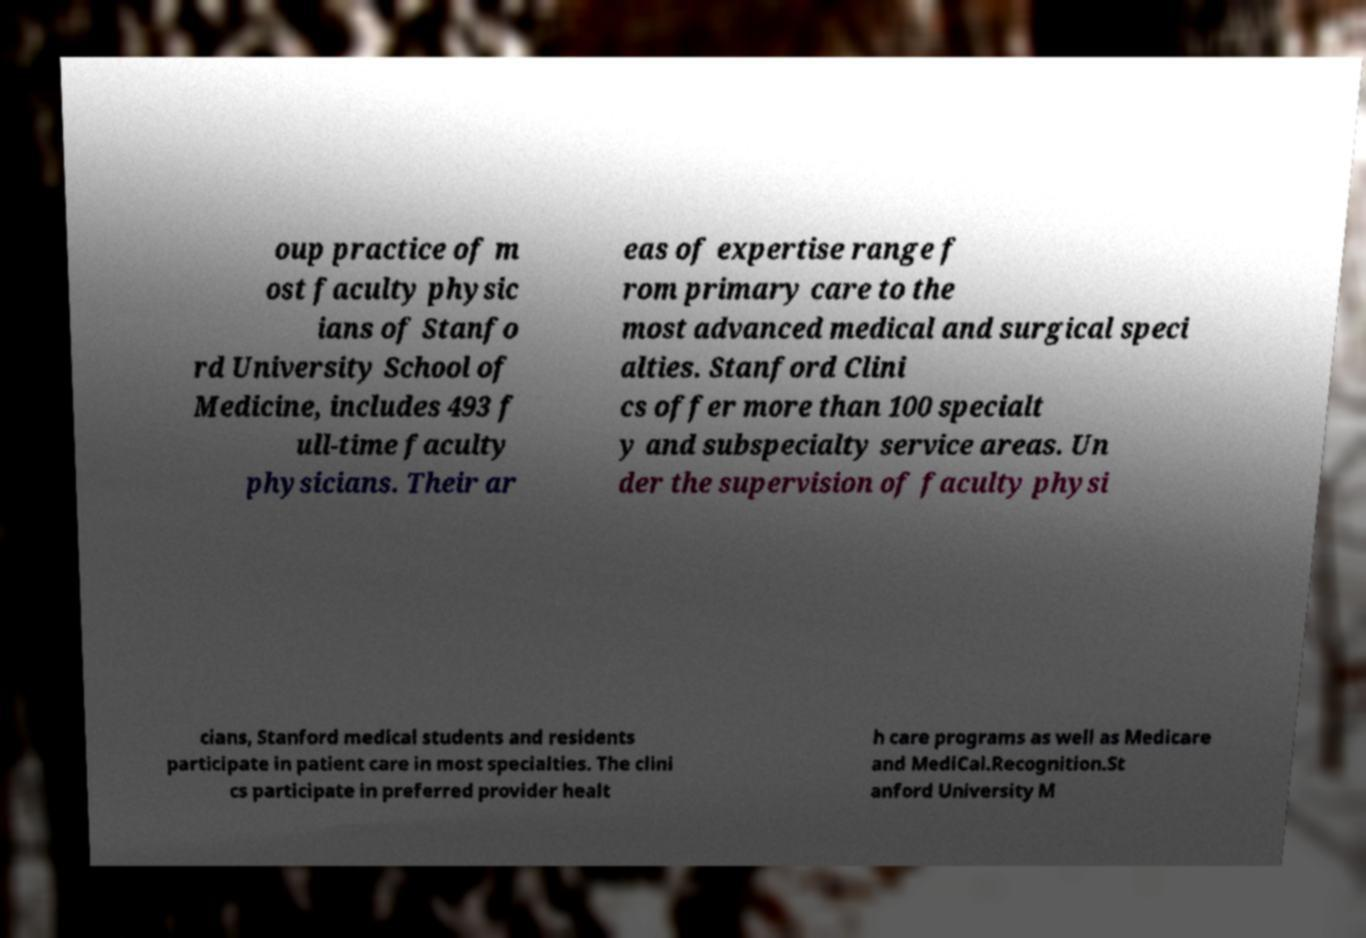What messages or text are displayed in this image? I need them in a readable, typed format. oup practice of m ost faculty physic ians of Stanfo rd University School of Medicine, includes 493 f ull-time faculty physicians. Their ar eas of expertise range f rom primary care to the most advanced medical and surgical speci alties. Stanford Clini cs offer more than 100 specialt y and subspecialty service areas. Un der the supervision of faculty physi cians, Stanford medical students and residents participate in patient care in most specialties. The clini cs participate in preferred provider healt h care programs as well as Medicare and MediCal.Recognition.St anford University M 